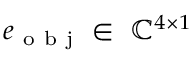<formula> <loc_0><loc_0><loc_500><loc_500>e _ { o b j } \in \ \mathbb { C } ^ { 4 \times 1 }</formula> 